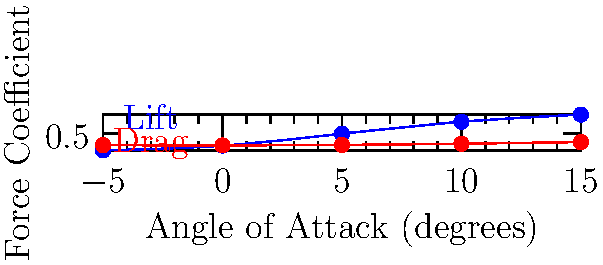As a young INC member advocating for aerospace development in Assam, you're analyzing the aerodynamic performance of a new aircraft design. The graph shows the lift and drag coefficients for an airfoil at various angles of attack. At which angle of attack does the lift-to-drag ratio (L/D) appear to be maximum, and how might this information be used to promote efficient air transportation in Assam? To determine the angle of attack with the maximum lift-to-drag ratio, we need to follow these steps:

1. Understand the graph:
   - Blue line represents the lift coefficient ($C_L$)
   - Red line represents the drag coefficient ($C_D$)
   - X-axis shows the angle of attack in degrees

2. Calculate the lift-to-drag ratio (L/D) for each angle:
   At -5°: $L/D = -0.2 / 0.02 = -10$
   At 0°: $L/D = 0 / 0.01 = 0$
   At 5°: $L/D = 0.5 / 0.03 \approx 16.67$
   At 10°: $L/D = 1.0 / 0.08 = 12.5$
   At 15°: $L/D = 1.3 / 0.15 \approx 8.67$

3. Identify the maximum L/D ratio:
   The highest L/D ratio is at 5° angle of attack.

4. Significance for Assam's air transportation:
   - Operating aircraft at this optimal angle of attack maximizes fuel efficiency.
   - Improved fuel efficiency leads to reduced operational costs and lower ticket prices.
   - This can make air travel more accessible to the people of Assam, promoting connectivity and economic growth.
   - Environmentally friendly as it reduces carbon emissions per passenger-kilometer.
   - Aligns with INC's vision for sustainable development and improved infrastructure in Assam.
Answer: 5° angle of attack; promotes fuel-efficient and accessible air transportation in Assam. 